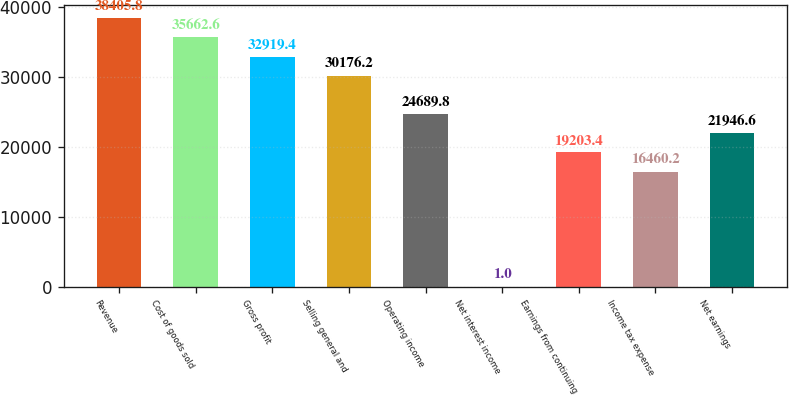<chart> <loc_0><loc_0><loc_500><loc_500><bar_chart><fcel>Revenue<fcel>Cost of goods sold<fcel>Gross profit<fcel>Selling general and<fcel>Operating income<fcel>Net interest income<fcel>Earnings from continuing<fcel>Income tax expense<fcel>Net earnings<nl><fcel>38405.8<fcel>35662.6<fcel>32919.4<fcel>30176.2<fcel>24689.8<fcel>1<fcel>19203.4<fcel>16460.2<fcel>21946.6<nl></chart> 